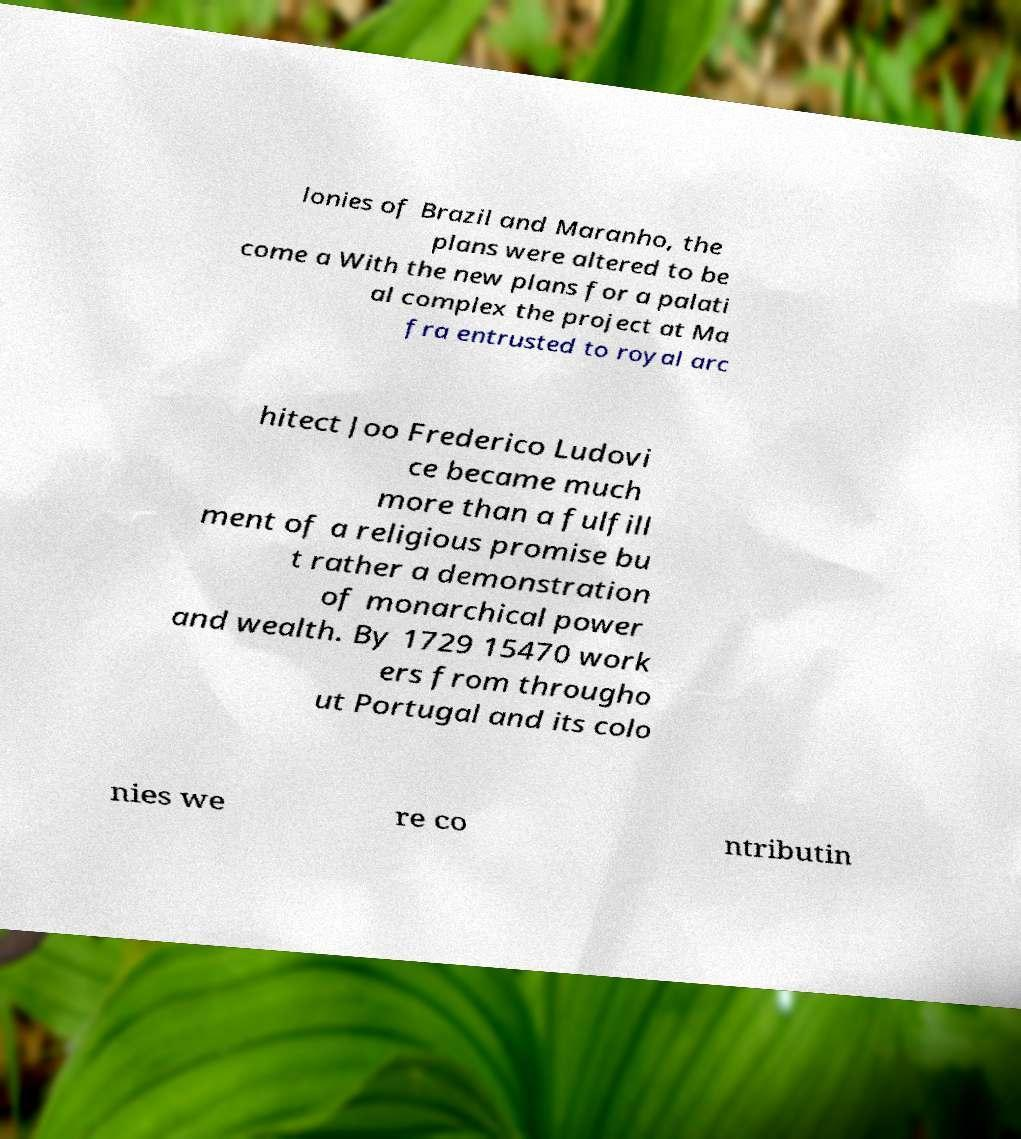Can you read and provide the text displayed in the image?This photo seems to have some interesting text. Can you extract and type it out for me? lonies of Brazil and Maranho, the plans were altered to be come a With the new plans for a palati al complex the project at Ma fra entrusted to royal arc hitect Joo Frederico Ludovi ce became much more than a fulfill ment of a religious promise bu t rather a demonstration of monarchical power and wealth. By 1729 15470 work ers from througho ut Portugal and its colo nies we re co ntributin 